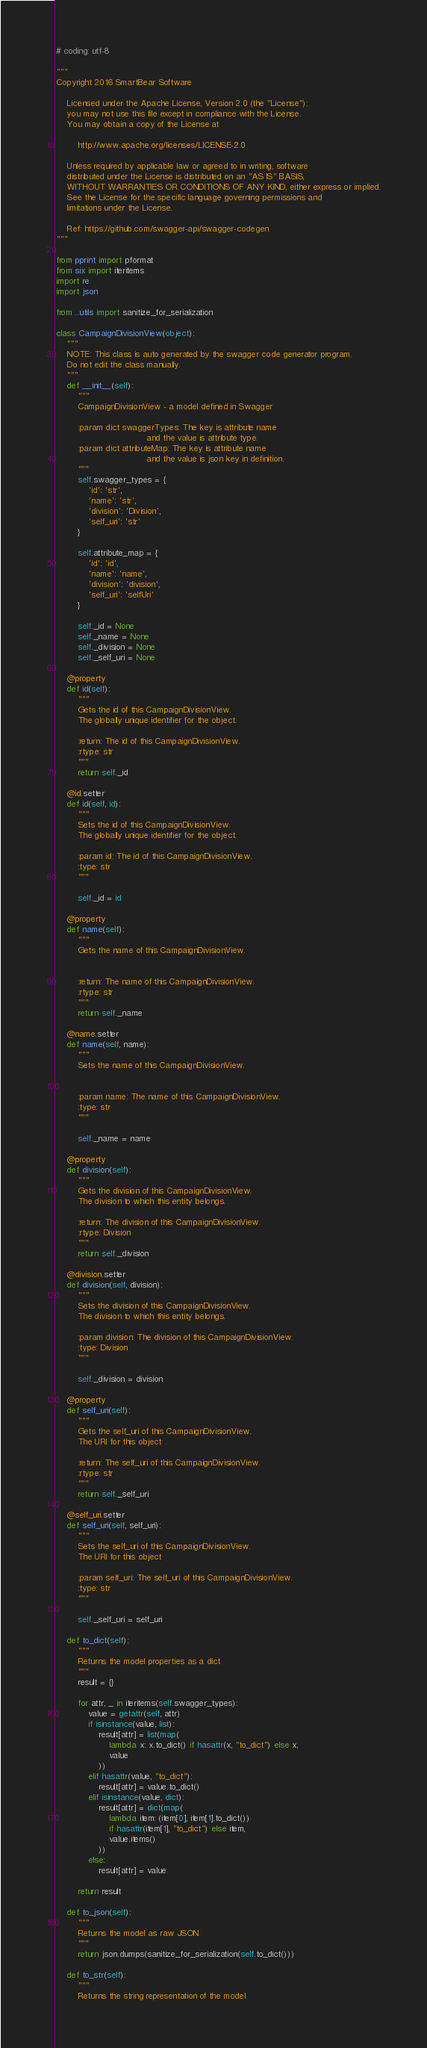<code> <loc_0><loc_0><loc_500><loc_500><_Python_># coding: utf-8

"""
Copyright 2016 SmartBear Software

    Licensed under the Apache License, Version 2.0 (the "License");
    you may not use this file except in compliance with the License.
    You may obtain a copy of the License at

        http://www.apache.org/licenses/LICENSE-2.0

    Unless required by applicable law or agreed to in writing, software
    distributed under the License is distributed on an "AS IS" BASIS,
    WITHOUT WARRANTIES OR CONDITIONS OF ANY KIND, either express or implied.
    See the License for the specific language governing permissions and
    limitations under the License.

    Ref: https://github.com/swagger-api/swagger-codegen
"""

from pprint import pformat
from six import iteritems
import re
import json

from ..utils import sanitize_for_serialization

class CampaignDivisionView(object):
    """
    NOTE: This class is auto generated by the swagger code generator program.
    Do not edit the class manually.
    """
    def __init__(self):
        """
        CampaignDivisionView - a model defined in Swagger

        :param dict swaggerTypes: The key is attribute name
                                  and the value is attribute type.
        :param dict attributeMap: The key is attribute name
                                  and the value is json key in definition.
        """
        self.swagger_types = {
            'id': 'str',
            'name': 'str',
            'division': 'Division',
            'self_uri': 'str'
        }

        self.attribute_map = {
            'id': 'id',
            'name': 'name',
            'division': 'division',
            'self_uri': 'selfUri'
        }

        self._id = None
        self._name = None
        self._division = None
        self._self_uri = None

    @property
    def id(self):
        """
        Gets the id of this CampaignDivisionView.
        The globally unique identifier for the object.

        :return: The id of this CampaignDivisionView.
        :rtype: str
        """
        return self._id

    @id.setter
    def id(self, id):
        """
        Sets the id of this CampaignDivisionView.
        The globally unique identifier for the object.

        :param id: The id of this CampaignDivisionView.
        :type: str
        """
        
        self._id = id

    @property
    def name(self):
        """
        Gets the name of this CampaignDivisionView.


        :return: The name of this CampaignDivisionView.
        :rtype: str
        """
        return self._name

    @name.setter
    def name(self, name):
        """
        Sets the name of this CampaignDivisionView.


        :param name: The name of this CampaignDivisionView.
        :type: str
        """
        
        self._name = name

    @property
    def division(self):
        """
        Gets the division of this CampaignDivisionView.
        The division to which this entity belongs.

        :return: The division of this CampaignDivisionView.
        :rtype: Division
        """
        return self._division

    @division.setter
    def division(self, division):
        """
        Sets the division of this CampaignDivisionView.
        The division to which this entity belongs.

        :param division: The division of this CampaignDivisionView.
        :type: Division
        """
        
        self._division = division

    @property
    def self_uri(self):
        """
        Gets the self_uri of this CampaignDivisionView.
        The URI for this object

        :return: The self_uri of this CampaignDivisionView.
        :rtype: str
        """
        return self._self_uri

    @self_uri.setter
    def self_uri(self, self_uri):
        """
        Sets the self_uri of this CampaignDivisionView.
        The URI for this object

        :param self_uri: The self_uri of this CampaignDivisionView.
        :type: str
        """
        
        self._self_uri = self_uri

    def to_dict(self):
        """
        Returns the model properties as a dict
        """
        result = {}

        for attr, _ in iteritems(self.swagger_types):
            value = getattr(self, attr)
            if isinstance(value, list):
                result[attr] = list(map(
                    lambda x: x.to_dict() if hasattr(x, "to_dict") else x,
                    value
                ))
            elif hasattr(value, "to_dict"):
                result[attr] = value.to_dict()
            elif isinstance(value, dict):
                result[attr] = dict(map(
                    lambda item: (item[0], item[1].to_dict())
                    if hasattr(item[1], "to_dict") else item,
                    value.items()
                ))
            else:
                result[attr] = value

        return result

    def to_json(self):
        """
        Returns the model as raw JSON
        """
        return json.dumps(sanitize_for_serialization(self.to_dict()))

    def to_str(self):
        """
        Returns the string representation of the model</code> 